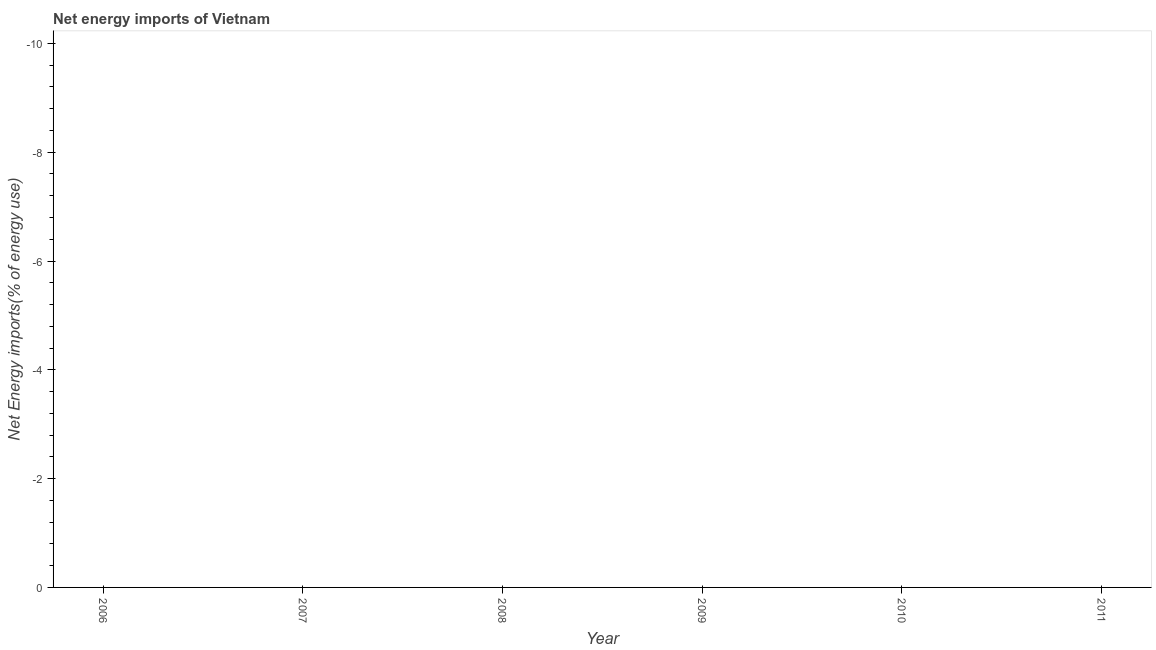What is the energy imports in 2007?
Ensure brevity in your answer.  0. Across all years, what is the minimum energy imports?
Ensure brevity in your answer.  0. What is the sum of the energy imports?
Provide a short and direct response. 0. What is the median energy imports?
Your response must be concise. 0. In how many years, is the energy imports greater than -3.6 %?
Your response must be concise. 0. In how many years, is the energy imports greater than the average energy imports taken over all years?
Offer a terse response. 0. How many lines are there?
Make the answer very short. 0. How many years are there in the graph?
Your answer should be very brief. 6. Does the graph contain any zero values?
Provide a short and direct response. Yes. What is the title of the graph?
Provide a succinct answer. Net energy imports of Vietnam. What is the label or title of the X-axis?
Keep it short and to the point. Year. What is the label or title of the Y-axis?
Your response must be concise. Net Energy imports(% of energy use). What is the Net Energy imports(% of energy use) of 2006?
Your answer should be very brief. 0. What is the Net Energy imports(% of energy use) in 2007?
Ensure brevity in your answer.  0. What is the Net Energy imports(% of energy use) in 2011?
Provide a succinct answer. 0. 